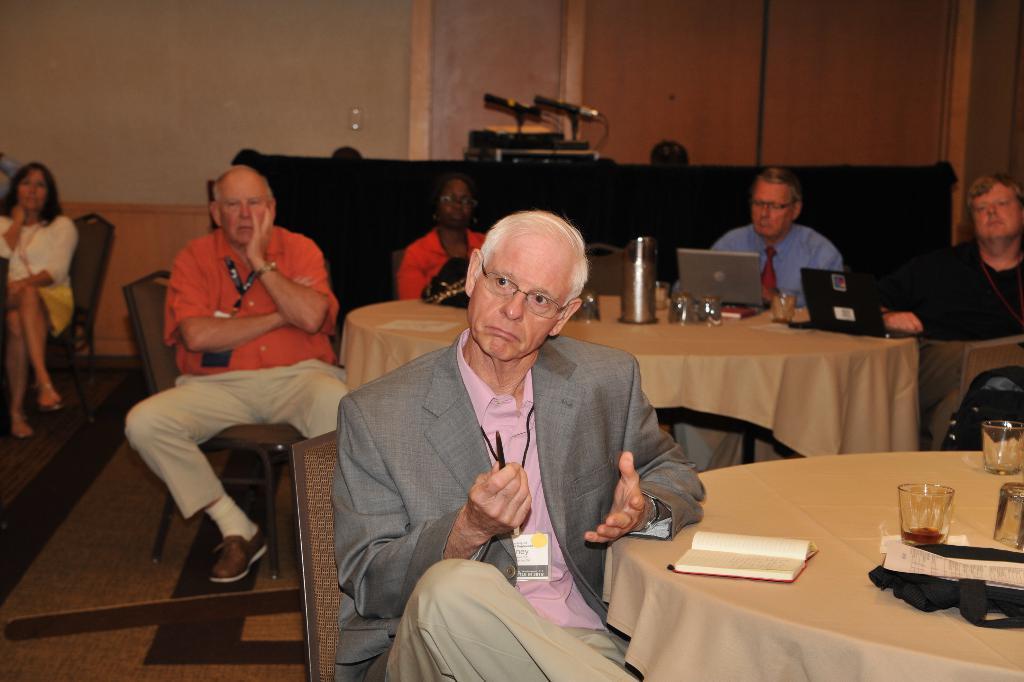Could you give a brief overview of what you see in this image? There are group of people sitting on the chairs. This is a table covered with cream colored cloth. There is a water jug,tumbler and laptops placed on the table. At background I can see some electronic devices and this is covered by a black cloth. 